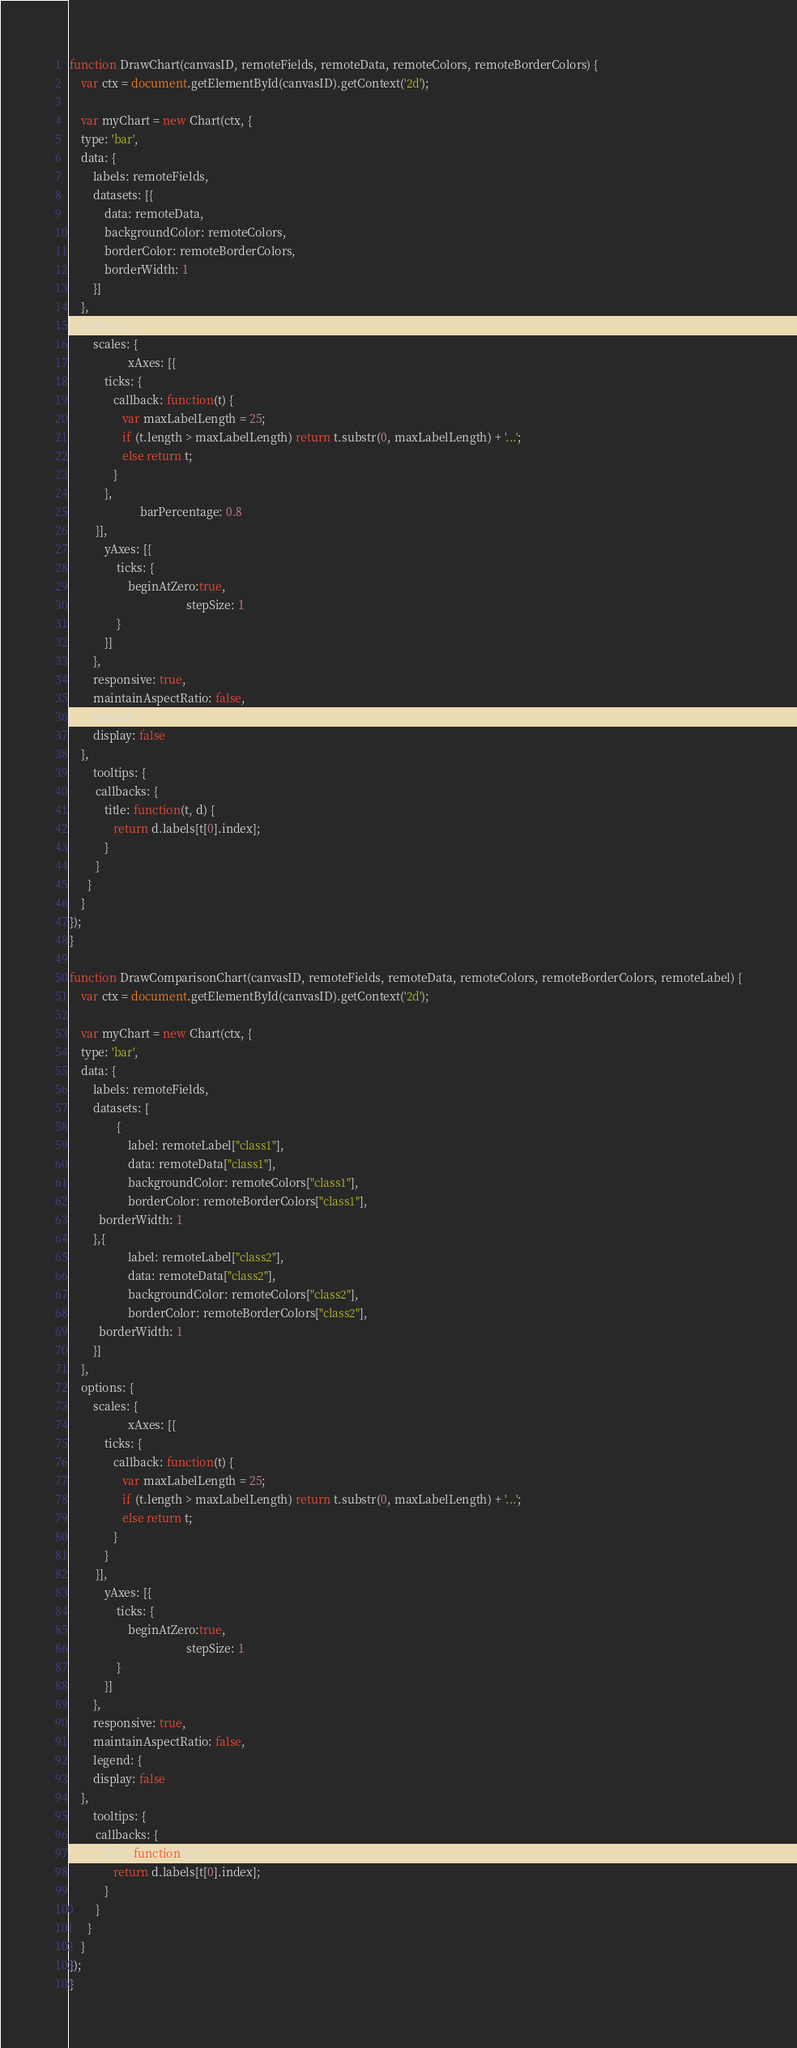Convert code to text. <code><loc_0><loc_0><loc_500><loc_500><_JavaScript_>function DrawChart(canvasID, remoteFields, remoteData, remoteColors, remoteBorderColors) {
	var ctx = document.getElementById(canvasID).getContext('2d');

	var myChart = new Chart(ctx, {
    type: 'bar',
    data: {
		labels: remoteFields,
        datasets: [{
			data: remoteData,
			backgroundColor: remoteColors,
			borderColor: remoteBorderColors,
            borderWidth: 1
        }]
    },
    options: {
        scales: {
					xAxes: [{
            ticks: {
               callback: function(t) {
                  var maxLabelLength = 25;
                  if (t.length > maxLabelLength) return t.substr(0, maxLabelLength) + '...';
                  else return t;
               }
            },
						barPercentage: 0.8
         }],
            yAxes: [{
                ticks: {
                    beginAtZero:true,
										stepSize: 1
                }
            }]
        },
		responsive: true,
		maintainAspectRatio: false,
		legend: {
        display: false
    },
		tooltips: {
         callbacks: {
            title: function(t, d) {
               return d.labels[t[0].index];
            }
         }
      }
    }
});
}

function DrawComparisonChart(canvasID, remoteFields, remoteData, remoteColors, remoteBorderColors, remoteLabel) {
	var ctx = document.getElementById(canvasID).getContext('2d');

	var myChart = new Chart(ctx, {
    type: 'bar',
    data: {
		labels: remoteFields,
        datasets: [
				{
					label: remoteLabel["class1"],
					data: remoteData["class1"],
					backgroundColor: remoteColors["class1"],
					borderColor: remoteBorderColors["class1"],
          borderWidth: 1
        },{
					label: remoteLabel["class2"],
					data: remoteData["class2"],
					backgroundColor: remoteColors["class2"],
					borderColor: remoteBorderColors["class2"],
          borderWidth: 1
        }]
    },
    options: {
        scales: {
					xAxes: [{
            ticks: {
               callback: function(t) {
                  var maxLabelLength = 25;
                  if (t.length > maxLabelLength) return t.substr(0, maxLabelLength) + '...';
                  else return t;
               }
            }
         }],
            yAxes: [{
                ticks: {
                    beginAtZero:true,
										stepSize: 1
                }
            }]
        },
		responsive: true,
		maintainAspectRatio: false,
		legend: {
        display: false
    },
		tooltips: {
         callbacks: {
            title: function(t, d) {
               return d.labels[t[0].index];
            }
         }
      }
    }
});
}
</code> 